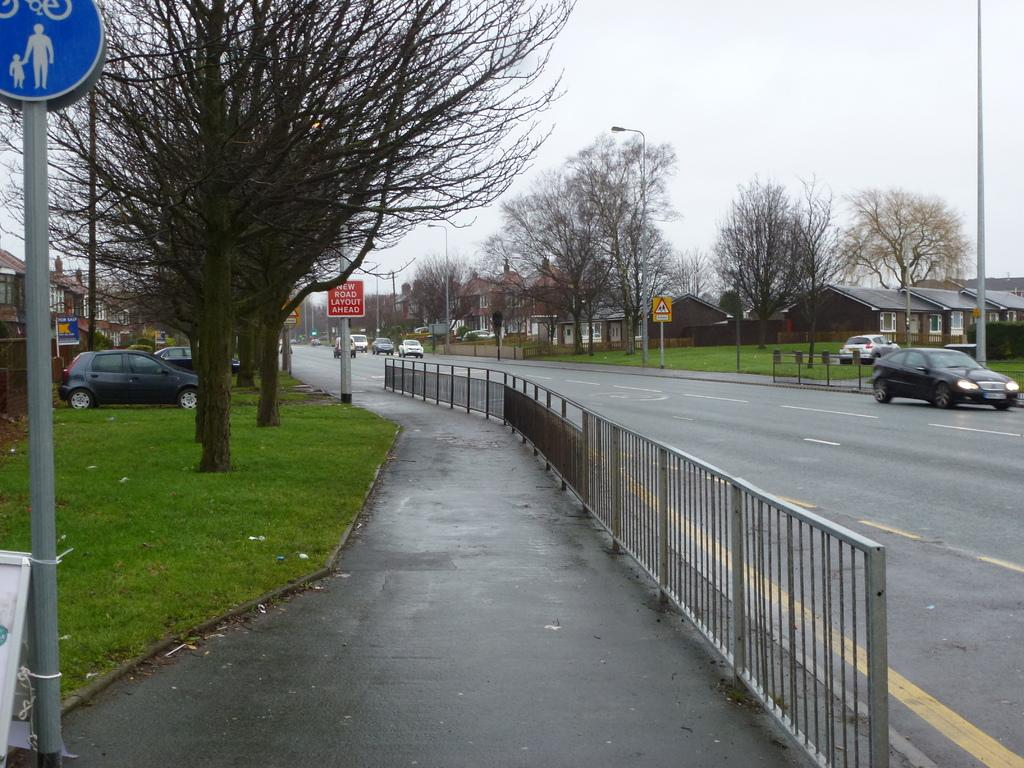What type of barrier can be seen in the image? There is a fence in the image. What type of vegetation is present in the image? There is grass in the image. What structures can be seen in the image? There are poles, boards, and houses in the image. What type of plants are visible in the image? There are trees in the image. What type of transportation is present in the image? There are vehicles in the image. What is visible in the background of the image? The sky is visible in the background of the image. What day of the week is the calendar showing in the image? There is no calendar present in the image. What type of advice might the grandmother give in the image? There is no grandmother present in the image. 